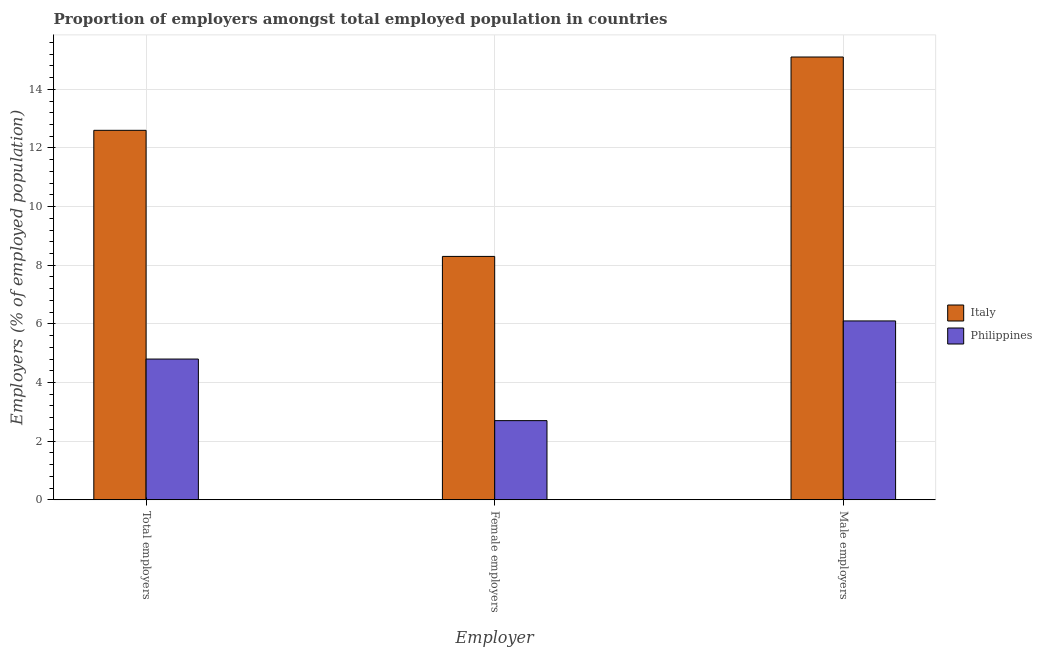How many different coloured bars are there?
Your answer should be compact. 2. How many bars are there on the 2nd tick from the left?
Your response must be concise. 2. What is the label of the 3rd group of bars from the left?
Your answer should be very brief. Male employers. What is the percentage of male employers in Philippines?
Give a very brief answer. 6.1. Across all countries, what is the maximum percentage of female employers?
Ensure brevity in your answer.  8.3. Across all countries, what is the minimum percentage of female employers?
Give a very brief answer. 2.7. What is the total percentage of female employers in the graph?
Offer a terse response. 11. What is the difference between the percentage of total employers in Italy and that in Philippines?
Ensure brevity in your answer.  7.8. What is the difference between the percentage of female employers in Philippines and the percentage of total employers in Italy?
Provide a short and direct response. -9.9. What is the average percentage of male employers per country?
Make the answer very short. 10.6. What is the difference between the percentage of total employers and percentage of male employers in Italy?
Offer a very short reply. -2.5. In how many countries, is the percentage of female employers greater than 11.2 %?
Offer a terse response. 0. What is the ratio of the percentage of total employers in Philippines to that in Italy?
Offer a very short reply. 0.38. Is the difference between the percentage of total employers in Italy and Philippines greater than the difference between the percentage of female employers in Italy and Philippines?
Your answer should be very brief. Yes. What is the difference between the highest and the second highest percentage of female employers?
Make the answer very short. 5.6. What is the difference between the highest and the lowest percentage of female employers?
Offer a very short reply. 5.6. In how many countries, is the percentage of female employers greater than the average percentage of female employers taken over all countries?
Make the answer very short. 1. Is it the case that in every country, the sum of the percentage of total employers and percentage of female employers is greater than the percentage of male employers?
Keep it short and to the point. Yes. How many bars are there?
Offer a very short reply. 6. How many countries are there in the graph?
Make the answer very short. 2. How many legend labels are there?
Ensure brevity in your answer.  2. What is the title of the graph?
Your answer should be compact. Proportion of employers amongst total employed population in countries. What is the label or title of the X-axis?
Provide a short and direct response. Employer. What is the label or title of the Y-axis?
Your response must be concise. Employers (% of employed population). What is the Employers (% of employed population) of Italy in Total employers?
Ensure brevity in your answer.  12.6. What is the Employers (% of employed population) in Philippines in Total employers?
Provide a succinct answer. 4.8. What is the Employers (% of employed population) of Italy in Female employers?
Your answer should be compact. 8.3. What is the Employers (% of employed population) in Philippines in Female employers?
Provide a short and direct response. 2.7. What is the Employers (% of employed population) of Italy in Male employers?
Keep it short and to the point. 15.1. What is the Employers (% of employed population) in Philippines in Male employers?
Your answer should be very brief. 6.1. Across all Employer, what is the maximum Employers (% of employed population) in Italy?
Provide a succinct answer. 15.1. Across all Employer, what is the maximum Employers (% of employed population) of Philippines?
Provide a short and direct response. 6.1. Across all Employer, what is the minimum Employers (% of employed population) of Italy?
Keep it short and to the point. 8.3. Across all Employer, what is the minimum Employers (% of employed population) in Philippines?
Offer a terse response. 2.7. What is the total Employers (% of employed population) of Philippines in the graph?
Keep it short and to the point. 13.6. What is the difference between the Employers (% of employed population) in Italy in Total employers and that in Female employers?
Provide a short and direct response. 4.3. What is the difference between the Employers (% of employed population) in Philippines in Total employers and that in Female employers?
Your answer should be compact. 2.1. What is the difference between the Employers (% of employed population) in Italy in Total employers and that in Male employers?
Offer a very short reply. -2.5. What is the difference between the Employers (% of employed population) in Italy in Female employers and that in Male employers?
Offer a terse response. -6.8. What is the difference between the Employers (% of employed population) of Philippines in Female employers and that in Male employers?
Provide a short and direct response. -3.4. What is the difference between the Employers (% of employed population) in Italy in Total employers and the Employers (% of employed population) in Philippines in Female employers?
Provide a succinct answer. 9.9. What is the difference between the Employers (% of employed population) of Italy in Female employers and the Employers (% of employed population) of Philippines in Male employers?
Provide a short and direct response. 2.2. What is the average Employers (% of employed population) in Italy per Employer?
Offer a very short reply. 12. What is the average Employers (% of employed population) of Philippines per Employer?
Your response must be concise. 4.53. What is the difference between the Employers (% of employed population) in Italy and Employers (% of employed population) in Philippines in Male employers?
Provide a short and direct response. 9. What is the ratio of the Employers (% of employed population) in Italy in Total employers to that in Female employers?
Keep it short and to the point. 1.52. What is the ratio of the Employers (% of employed population) in Philippines in Total employers to that in Female employers?
Provide a succinct answer. 1.78. What is the ratio of the Employers (% of employed population) of Italy in Total employers to that in Male employers?
Offer a terse response. 0.83. What is the ratio of the Employers (% of employed population) of Philippines in Total employers to that in Male employers?
Your response must be concise. 0.79. What is the ratio of the Employers (% of employed population) of Italy in Female employers to that in Male employers?
Offer a terse response. 0.55. What is the ratio of the Employers (% of employed population) of Philippines in Female employers to that in Male employers?
Your answer should be compact. 0.44. What is the difference between the highest and the lowest Employers (% of employed population) in Italy?
Offer a very short reply. 6.8. What is the difference between the highest and the lowest Employers (% of employed population) of Philippines?
Ensure brevity in your answer.  3.4. 